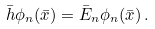<formula> <loc_0><loc_0><loc_500><loc_500>\bar { h } \phi _ { n } ( \bar { x } ) = \bar { E } _ { n } \phi _ { n } ( \bar { x } ) \, .</formula> 